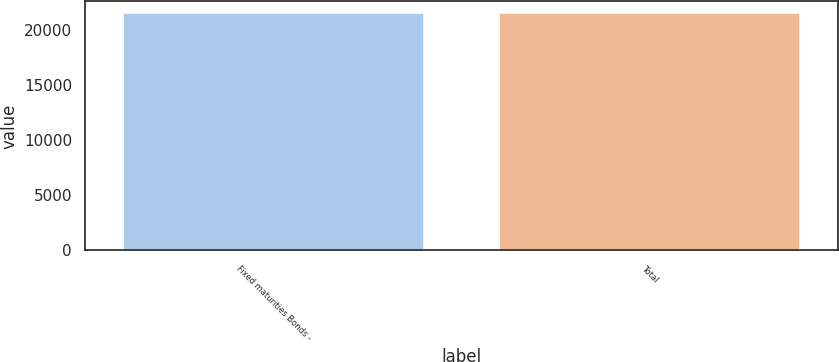<chart> <loc_0><loc_0><loc_500><loc_500><bar_chart><fcel>Fixed maturities Bonds -<fcel>Total<nl><fcel>21528<fcel>21528.1<nl></chart> 